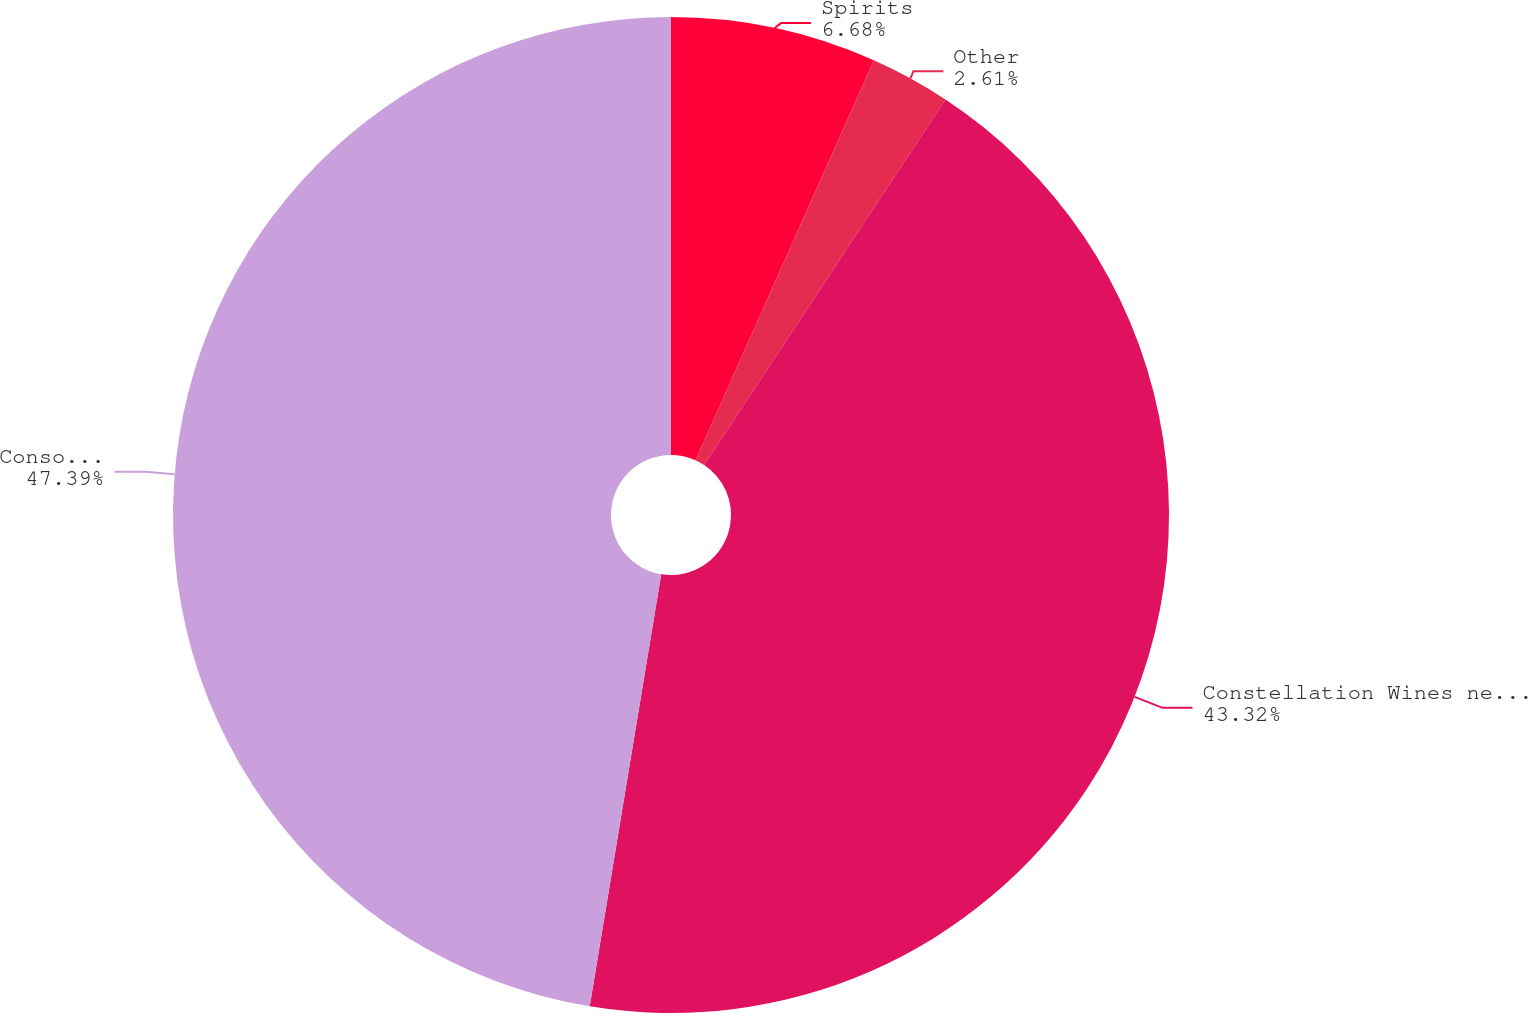Convert chart. <chart><loc_0><loc_0><loc_500><loc_500><pie_chart><fcel>Spirits<fcel>Other<fcel>Constellation Wines net sales<fcel>Consolidated Net Sales<nl><fcel>6.68%<fcel>2.61%<fcel>43.32%<fcel>47.39%<nl></chart> 